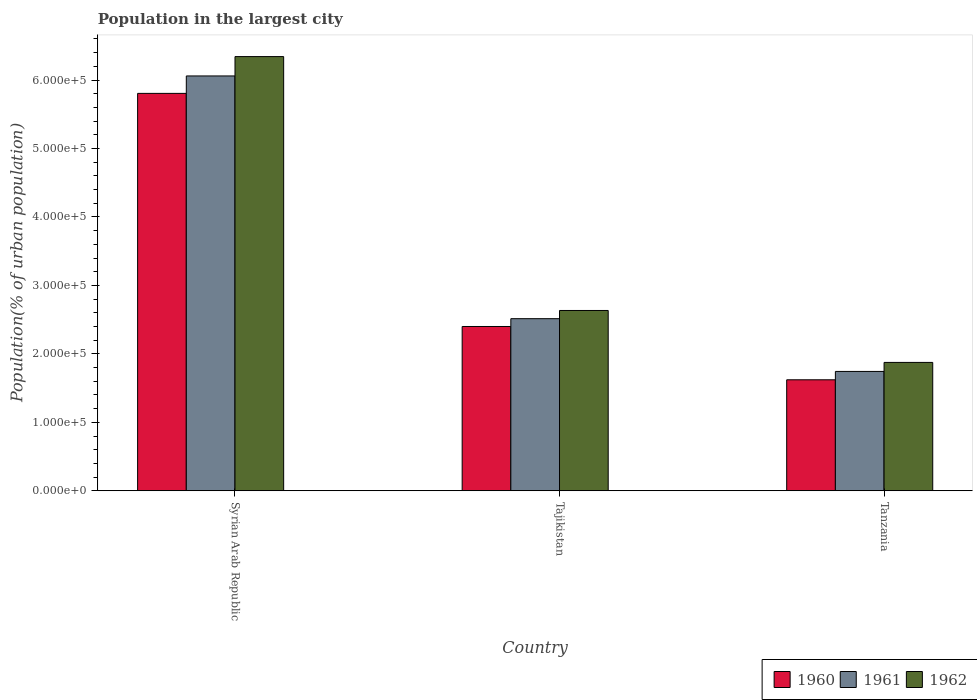How many groups of bars are there?
Offer a very short reply. 3. Are the number of bars on each tick of the X-axis equal?
Provide a succinct answer. Yes. How many bars are there on the 2nd tick from the right?
Offer a terse response. 3. What is the label of the 1st group of bars from the left?
Your answer should be compact. Syrian Arab Republic. What is the population in the largest city in 1960 in Tajikistan?
Your answer should be very brief. 2.40e+05. Across all countries, what is the maximum population in the largest city in 1961?
Your answer should be very brief. 6.06e+05. Across all countries, what is the minimum population in the largest city in 1961?
Offer a terse response. 1.74e+05. In which country was the population in the largest city in 1961 maximum?
Provide a succinct answer. Syrian Arab Republic. In which country was the population in the largest city in 1962 minimum?
Ensure brevity in your answer.  Tanzania. What is the total population in the largest city in 1961 in the graph?
Give a very brief answer. 1.03e+06. What is the difference between the population in the largest city in 1962 in Tajikistan and that in Tanzania?
Keep it short and to the point. 7.59e+04. What is the difference between the population in the largest city in 1962 in Tanzania and the population in the largest city in 1960 in Tajikistan?
Offer a terse response. -5.25e+04. What is the average population in the largest city in 1962 per country?
Your answer should be very brief. 3.62e+05. What is the difference between the population in the largest city of/in 1961 and population in the largest city of/in 1962 in Tajikistan?
Provide a short and direct response. -1.20e+04. In how many countries, is the population in the largest city in 1962 greater than 20000 %?
Ensure brevity in your answer.  3. What is the ratio of the population in the largest city in 1960 in Syrian Arab Republic to that in Tajikistan?
Make the answer very short. 2.42. Is the population in the largest city in 1960 in Syrian Arab Republic less than that in Tajikistan?
Your answer should be very brief. No. What is the difference between the highest and the second highest population in the largest city in 1961?
Make the answer very short. 4.32e+05. What is the difference between the highest and the lowest population in the largest city in 1961?
Your response must be concise. 4.32e+05. In how many countries, is the population in the largest city in 1962 greater than the average population in the largest city in 1962 taken over all countries?
Provide a succinct answer. 1. What does the 3rd bar from the left in Syrian Arab Republic represents?
Keep it short and to the point. 1962. What does the 1st bar from the right in Tanzania represents?
Ensure brevity in your answer.  1962. Is it the case that in every country, the sum of the population in the largest city in 1960 and population in the largest city in 1962 is greater than the population in the largest city in 1961?
Ensure brevity in your answer.  Yes. Are all the bars in the graph horizontal?
Ensure brevity in your answer.  No. What is the difference between two consecutive major ticks on the Y-axis?
Make the answer very short. 1.00e+05. How many legend labels are there?
Give a very brief answer. 3. What is the title of the graph?
Keep it short and to the point. Population in the largest city. Does "2002" appear as one of the legend labels in the graph?
Give a very brief answer. No. What is the label or title of the Y-axis?
Your response must be concise. Population(% of urban population). What is the Population(% of urban population) of 1960 in Syrian Arab Republic?
Ensure brevity in your answer.  5.80e+05. What is the Population(% of urban population) in 1961 in Syrian Arab Republic?
Your answer should be very brief. 6.06e+05. What is the Population(% of urban population) of 1962 in Syrian Arab Republic?
Ensure brevity in your answer.  6.34e+05. What is the Population(% of urban population) in 1960 in Tajikistan?
Your answer should be compact. 2.40e+05. What is the Population(% of urban population) in 1961 in Tajikistan?
Offer a very short reply. 2.51e+05. What is the Population(% of urban population) of 1962 in Tajikistan?
Ensure brevity in your answer.  2.63e+05. What is the Population(% of urban population) in 1960 in Tanzania?
Provide a succinct answer. 1.62e+05. What is the Population(% of urban population) in 1961 in Tanzania?
Keep it short and to the point. 1.74e+05. What is the Population(% of urban population) in 1962 in Tanzania?
Offer a terse response. 1.88e+05. Across all countries, what is the maximum Population(% of urban population) in 1960?
Your answer should be very brief. 5.80e+05. Across all countries, what is the maximum Population(% of urban population) in 1961?
Ensure brevity in your answer.  6.06e+05. Across all countries, what is the maximum Population(% of urban population) of 1962?
Offer a terse response. 6.34e+05. Across all countries, what is the minimum Population(% of urban population) in 1960?
Your answer should be very brief. 1.62e+05. Across all countries, what is the minimum Population(% of urban population) in 1961?
Your answer should be very brief. 1.74e+05. Across all countries, what is the minimum Population(% of urban population) in 1962?
Offer a very short reply. 1.88e+05. What is the total Population(% of urban population) of 1960 in the graph?
Make the answer very short. 9.83e+05. What is the total Population(% of urban population) in 1961 in the graph?
Make the answer very short. 1.03e+06. What is the total Population(% of urban population) of 1962 in the graph?
Give a very brief answer. 1.09e+06. What is the difference between the Population(% of urban population) of 1960 in Syrian Arab Republic and that in Tajikistan?
Keep it short and to the point. 3.40e+05. What is the difference between the Population(% of urban population) in 1961 in Syrian Arab Republic and that in Tajikistan?
Your response must be concise. 3.55e+05. What is the difference between the Population(% of urban population) of 1962 in Syrian Arab Republic and that in Tajikistan?
Make the answer very short. 3.71e+05. What is the difference between the Population(% of urban population) in 1960 in Syrian Arab Republic and that in Tanzania?
Offer a terse response. 4.18e+05. What is the difference between the Population(% of urban population) in 1961 in Syrian Arab Republic and that in Tanzania?
Provide a short and direct response. 4.32e+05. What is the difference between the Population(% of urban population) in 1962 in Syrian Arab Republic and that in Tanzania?
Provide a short and direct response. 4.47e+05. What is the difference between the Population(% of urban population) in 1960 in Tajikistan and that in Tanzania?
Provide a succinct answer. 7.79e+04. What is the difference between the Population(% of urban population) of 1961 in Tajikistan and that in Tanzania?
Give a very brief answer. 7.70e+04. What is the difference between the Population(% of urban population) of 1962 in Tajikistan and that in Tanzania?
Your response must be concise. 7.59e+04. What is the difference between the Population(% of urban population) in 1960 in Syrian Arab Republic and the Population(% of urban population) in 1961 in Tajikistan?
Provide a short and direct response. 3.29e+05. What is the difference between the Population(% of urban population) in 1960 in Syrian Arab Republic and the Population(% of urban population) in 1962 in Tajikistan?
Your answer should be very brief. 3.17e+05. What is the difference between the Population(% of urban population) of 1961 in Syrian Arab Republic and the Population(% of urban population) of 1962 in Tajikistan?
Give a very brief answer. 3.43e+05. What is the difference between the Population(% of urban population) of 1960 in Syrian Arab Republic and the Population(% of urban population) of 1961 in Tanzania?
Provide a succinct answer. 4.06e+05. What is the difference between the Population(% of urban population) of 1960 in Syrian Arab Republic and the Population(% of urban population) of 1962 in Tanzania?
Your response must be concise. 3.93e+05. What is the difference between the Population(% of urban population) in 1961 in Syrian Arab Republic and the Population(% of urban population) in 1962 in Tanzania?
Make the answer very short. 4.18e+05. What is the difference between the Population(% of urban population) in 1960 in Tajikistan and the Population(% of urban population) in 1961 in Tanzania?
Offer a terse response. 6.56e+04. What is the difference between the Population(% of urban population) in 1960 in Tajikistan and the Population(% of urban population) in 1962 in Tanzania?
Your answer should be very brief. 5.25e+04. What is the difference between the Population(% of urban population) in 1961 in Tajikistan and the Population(% of urban population) in 1962 in Tanzania?
Ensure brevity in your answer.  6.39e+04. What is the average Population(% of urban population) of 1960 per country?
Offer a very short reply. 3.28e+05. What is the average Population(% of urban population) of 1961 per country?
Provide a succinct answer. 3.44e+05. What is the average Population(% of urban population) of 1962 per country?
Give a very brief answer. 3.62e+05. What is the difference between the Population(% of urban population) in 1960 and Population(% of urban population) in 1961 in Syrian Arab Republic?
Make the answer very short. -2.55e+04. What is the difference between the Population(% of urban population) of 1960 and Population(% of urban population) of 1962 in Syrian Arab Republic?
Offer a very short reply. -5.37e+04. What is the difference between the Population(% of urban population) in 1961 and Population(% of urban population) in 1962 in Syrian Arab Republic?
Make the answer very short. -2.83e+04. What is the difference between the Population(% of urban population) of 1960 and Population(% of urban population) of 1961 in Tajikistan?
Make the answer very short. -1.14e+04. What is the difference between the Population(% of urban population) of 1960 and Population(% of urban population) of 1962 in Tajikistan?
Provide a short and direct response. -2.34e+04. What is the difference between the Population(% of urban population) of 1961 and Population(% of urban population) of 1962 in Tajikistan?
Give a very brief answer. -1.20e+04. What is the difference between the Population(% of urban population) of 1960 and Population(% of urban population) of 1961 in Tanzania?
Your response must be concise. -1.22e+04. What is the difference between the Population(% of urban population) in 1960 and Population(% of urban population) in 1962 in Tanzania?
Give a very brief answer. -2.54e+04. What is the difference between the Population(% of urban population) of 1961 and Population(% of urban population) of 1962 in Tanzania?
Ensure brevity in your answer.  -1.32e+04. What is the ratio of the Population(% of urban population) of 1960 in Syrian Arab Republic to that in Tajikistan?
Give a very brief answer. 2.42. What is the ratio of the Population(% of urban population) of 1961 in Syrian Arab Republic to that in Tajikistan?
Give a very brief answer. 2.41. What is the ratio of the Population(% of urban population) of 1962 in Syrian Arab Republic to that in Tajikistan?
Your answer should be compact. 2.41. What is the ratio of the Population(% of urban population) in 1960 in Syrian Arab Republic to that in Tanzania?
Your response must be concise. 3.58. What is the ratio of the Population(% of urban population) of 1961 in Syrian Arab Republic to that in Tanzania?
Make the answer very short. 3.48. What is the ratio of the Population(% of urban population) in 1962 in Syrian Arab Republic to that in Tanzania?
Ensure brevity in your answer.  3.38. What is the ratio of the Population(% of urban population) in 1960 in Tajikistan to that in Tanzania?
Provide a short and direct response. 1.48. What is the ratio of the Population(% of urban population) of 1961 in Tajikistan to that in Tanzania?
Your answer should be very brief. 1.44. What is the ratio of the Population(% of urban population) of 1962 in Tajikistan to that in Tanzania?
Your answer should be compact. 1.4. What is the difference between the highest and the second highest Population(% of urban population) in 1960?
Offer a very short reply. 3.40e+05. What is the difference between the highest and the second highest Population(% of urban population) of 1961?
Offer a terse response. 3.55e+05. What is the difference between the highest and the second highest Population(% of urban population) of 1962?
Offer a terse response. 3.71e+05. What is the difference between the highest and the lowest Population(% of urban population) of 1960?
Give a very brief answer. 4.18e+05. What is the difference between the highest and the lowest Population(% of urban population) of 1961?
Your answer should be compact. 4.32e+05. What is the difference between the highest and the lowest Population(% of urban population) in 1962?
Your response must be concise. 4.47e+05. 